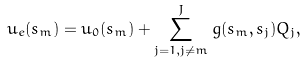<formula> <loc_0><loc_0><loc_500><loc_500>u _ { e } ( s _ { m } ) = u _ { 0 } ( s _ { m } ) + \sum ^ { J } _ { j = 1 , j \not = m } g ( s _ { m } , s _ { j } ) Q _ { j } ,</formula> 